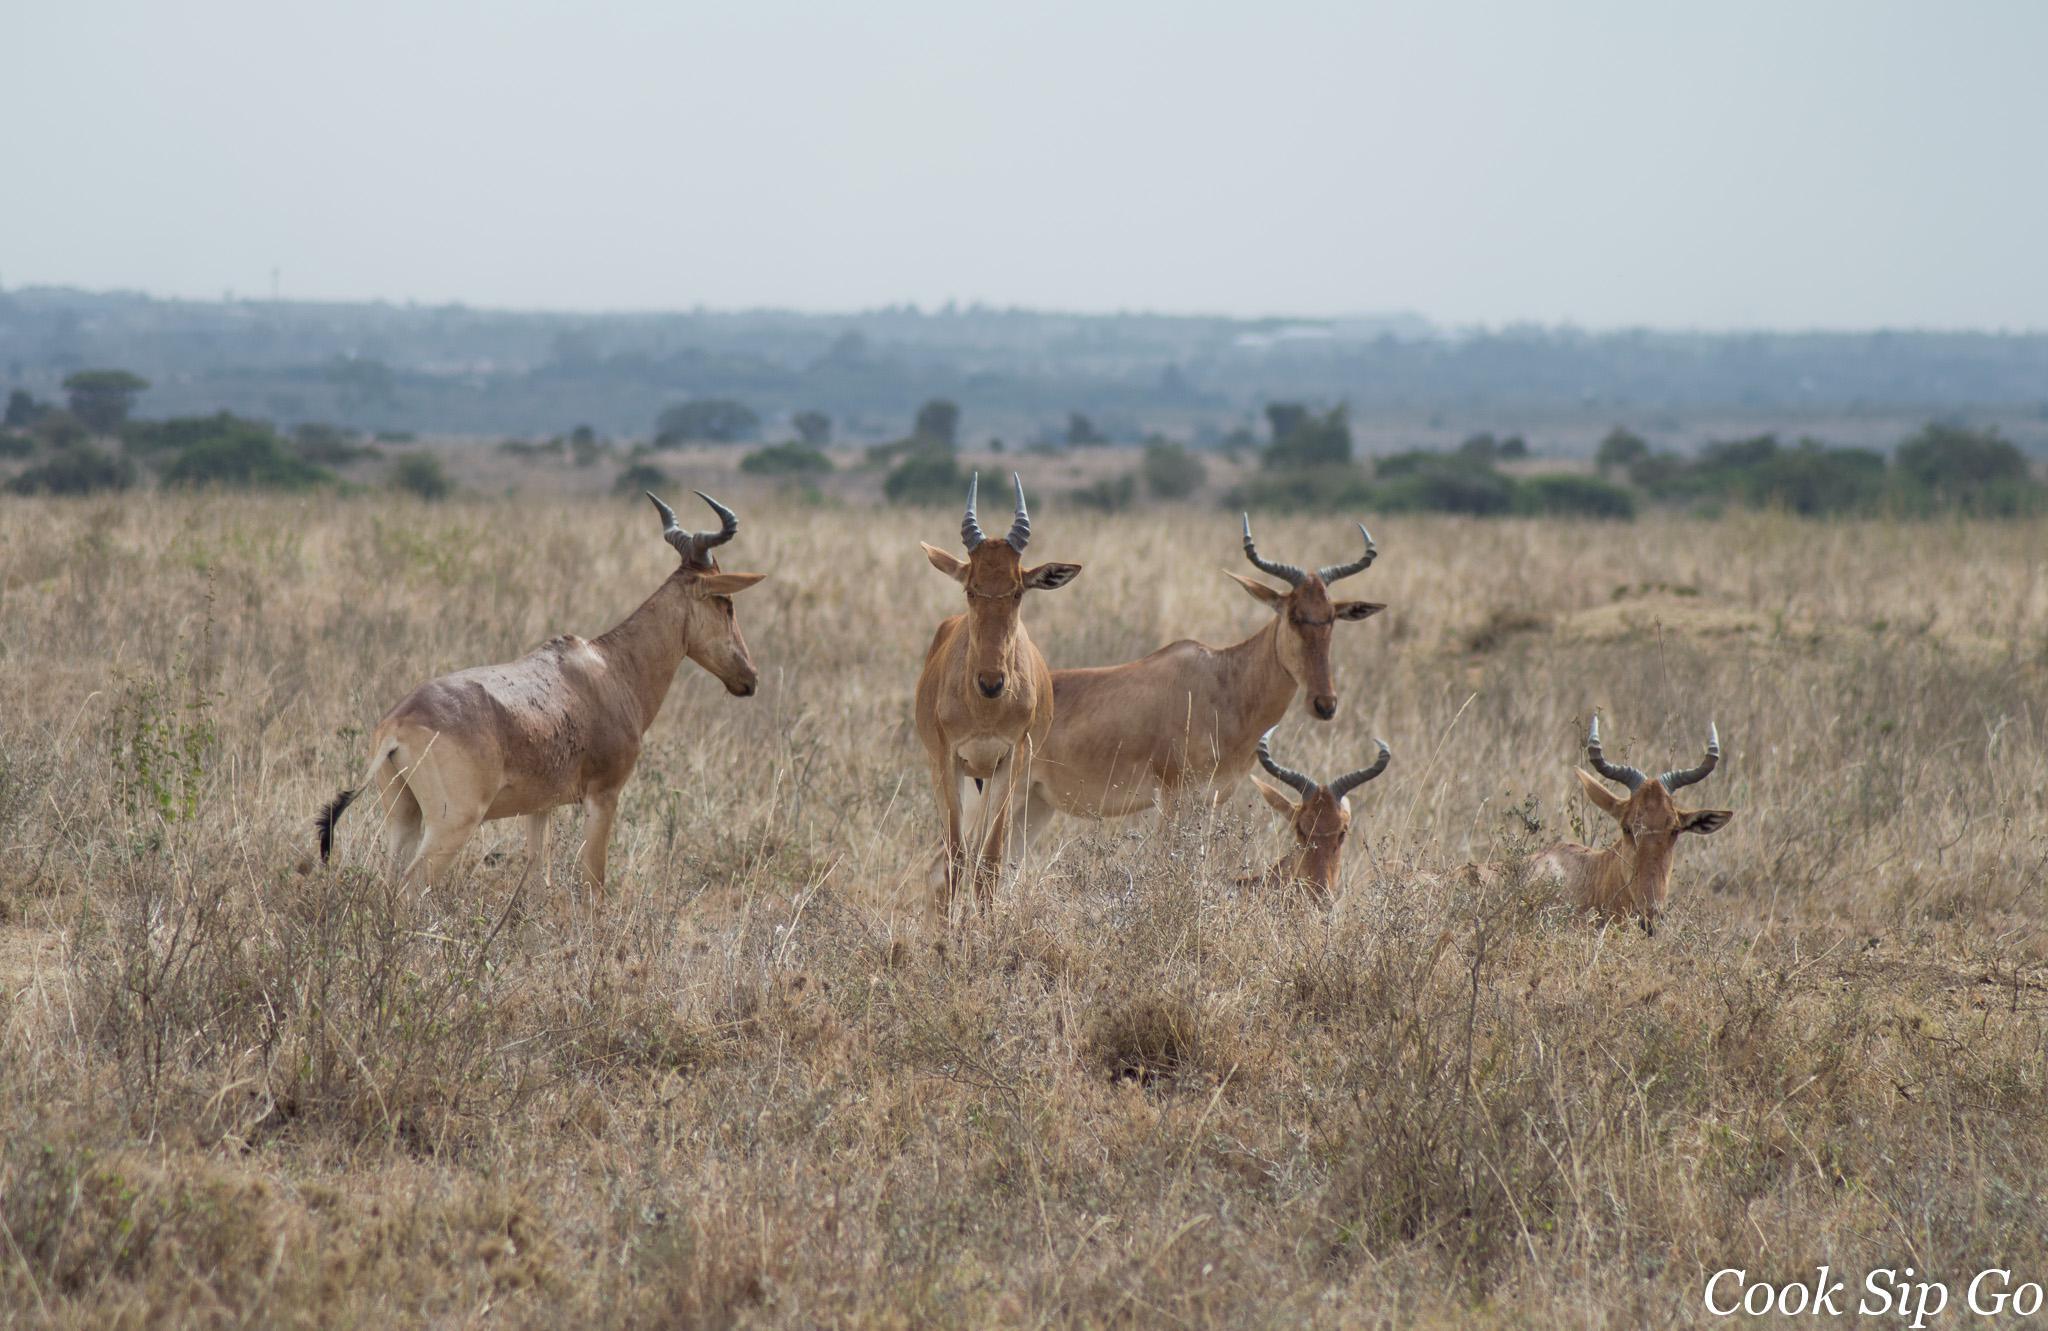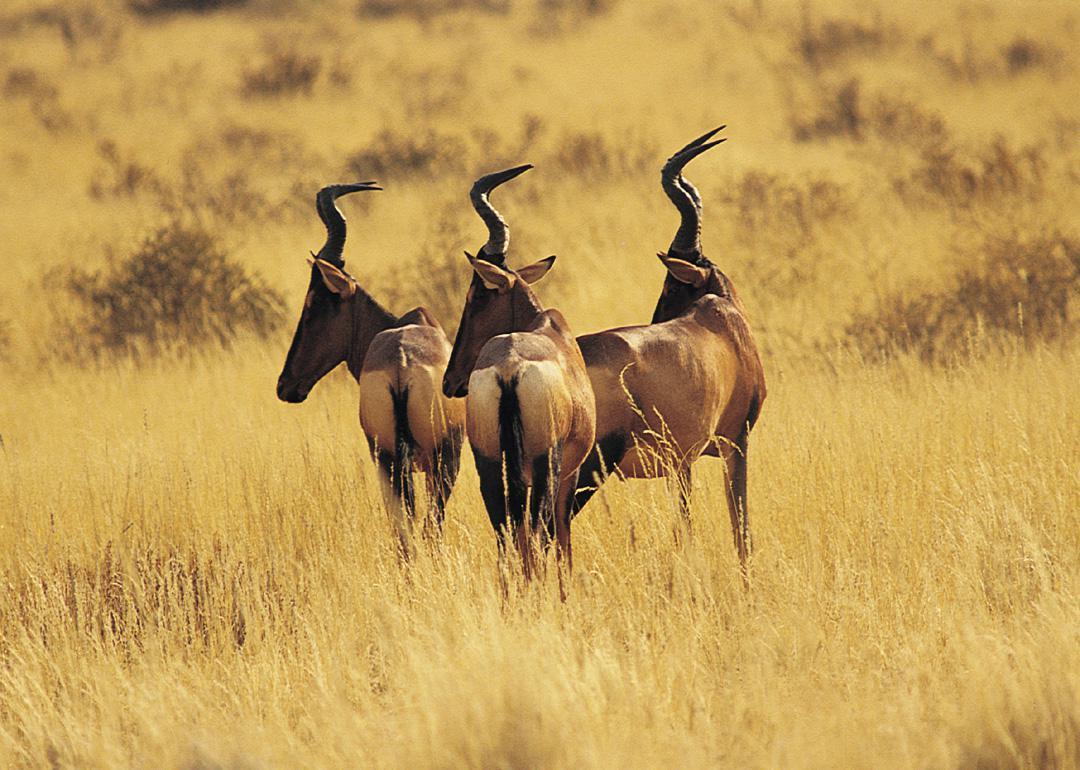The first image is the image on the left, the second image is the image on the right. Assess this claim about the two images: "There are at most 6 antelopes in at least one of the images.". Correct or not? Answer yes or no. Yes. The first image is the image on the left, the second image is the image on the right. For the images shown, is this caption "At least two horned animals are standing with their rears directly facing the camera, showing very dark tails on pale hinds." true? Answer yes or no. Yes. 